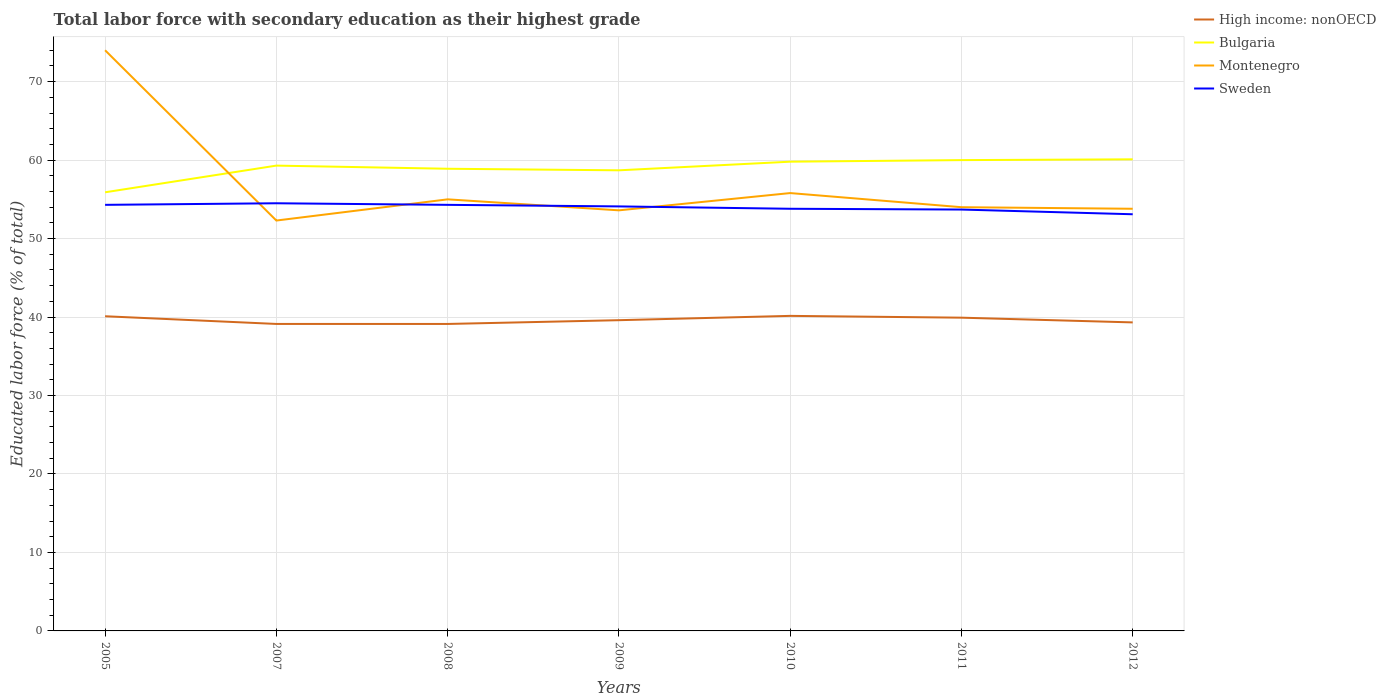Does the line corresponding to Montenegro intersect with the line corresponding to Sweden?
Your response must be concise. Yes. Across all years, what is the maximum percentage of total labor force with primary education in High income: nonOECD?
Keep it short and to the point. 39.12. In which year was the percentage of total labor force with primary education in Bulgaria maximum?
Ensure brevity in your answer.  2005. What is the total percentage of total labor force with primary education in High income: nonOECD in the graph?
Make the answer very short. -0.48. What is the difference between the highest and the second highest percentage of total labor force with primary education in Bulgaria?
Ensure brevity in your answer.  4.2. How many lines are there?
Offer a terse response. 4. Does the graph contain any zero values?
Your answer should be compact. No. How many legend labels are there?
Your response must be concise. 4. What is the title of the graph?
Your response must be concise. Total labor force with secondary education as their highest grade. What is the label or title of the Y-axis?
Keep it short and to the point. Educated labor force (% of total). What is the Educated labor force (% of total) of High income: nonOECD in 2005?
Your response must be concise. 40.1. What is the Educated labor force (% of total) in Bulgaria in 2005?
Your answer should be very brief. 55.9. What is the Educated labor force (% of total) in Sweden in 2005?
Make the answer very short. 54.3. What is the Educated labor force (% of total) of High income: nonOECD in 2007?
Keep it short and to the point. 39.12. What is the Educated labor force (% of total) of Bulgaria in 2007?
Ensure brevity in your answer.  59.3. What is the Educated labor force (% of total) in Montenegro in 2007?
Keep it short and to the point. 52.3. What is the Educated labor force (% of total) of Sweden in 2007?
Offer a terse response. 54.5. What is the Educated labor force (% of total) of High income: nonOECD in 2008?
Provide a short and direct response. 39.12. What is the Educated labor force (% of total) in Bulgaria in 2008?
Provide a short and direct response. 58.9. What is the Educated labor force (% of total) in Montenegro in 2008?
Keep it short and to the point. 55. What is the Educated labor force (% of total) in Sweden in 2008?
Ensure brevity in your answer.  54.3. What is the Educated labor force (% of total) in High income: nonOECD in 2009?
Offer a terse response. 39.6. What is the Educated labor force (% of total) in Bulgaria in 2009?
Ensure brevity in your answer.  58.7. What is the Educated labor force (% of total) of Montenegro in 2009?
Your response must be concise. 53.6. What is the Educated labor force (% of total) in Sweden in 2009?
Provide a succinct answer. 54.1. What is the Educated labor force (% of total) in High income: nonOECD in 2010?
Keep it short and to the point. 40.15. What is the Educated labor force (% of total) in Bulgaria in 2010?
Ensure brevity in your answer.  59.8. What is the Educated labor force (% of total) of Montenegro in 2010?
Provide a succinct answer. 55.8. What is the Educated labor force (% of total) in Sweden in 2010?
Offer a very short reply. 53.8. What is the Educated labor force (% of total) of High income: nonOECD in 2011?
Give a very brief answer. 39.92. What is the Educated labor force (% of total) in Montenegro in 2011?
Offer a very short reply. 54. What is the Educated labor force (% of total) in Sweden in 2011?
Your answer should be very brief. 53.7. What is the Educated labor force (% of total) of High income: nonOECD in 2012?
Provide a succinct answer. 39.32. What is the Educated labor force (% of total) in Bulgaria in 2012?
Give a very brief answer. 60.1. What is the Educated labor force (% of total) in Montenegro in 2012?
Your answer should be compact. 53.8. What is the Educated labor force (% of total) of Sweden in 2012?
Keep it short and to the point. 53.1. Across all years, what is the maximum Educated labor force (% of total) in High income: nonOECD?
Your response must be concise. 40.15. Across all years, what is the maximum Educated labor force (% of total) in Bulgaria?
Your response must be concise. 60.1. Across all years, what is the maximum Educated labor force (% of total) in Sweden?
Keep it short and to the point. 54.5. Across all years, what is the minimum Educated labor force (% of total) of High income: nonOECD?
Provide a succinct answer. 39.12. Across all years, what is the minimum Educated labor force (% of total) of Bulgaria?
Give a very brief answer. 55.9. Across all years, what is the minimum Educated labor force (% of total) of Montenegro?
Offer a very short reply. 52.3. Across all years, what is the minimum Educated labor force (% of total) in Sweden?
Give a very brief answer. 53.1. What is the total Educated labor force (% of total) of High income: nonOECD in the graph?
Your answer should be compact. 277.33. What is the total Educated labor force (% of total) of Bulgaria in the graph?
Make the answer very short. 412.7. What is the total Educated labor force (% of total) of Montenegro in the graph?
Your response must be concise. 398.5. What is the total Educated labor force (% of total) of Sweden in the graph?
Keep it short and to the point. 377.8. What is the difference between the Educated labor force (% of total) in High income: nonOECD in 2005 and that in 2007?
Your response must be concise. 0.98. What is the difference between the Educated labor force (% of total) in Montenegro in 2005 and that in 2007?
Your response must be concise. 21.7. What is the difference between the Educated labor force (% of total) of Sweden in 2005 and that in 2007?
Give a very brief answer. -0.2. What is the difference between the Educated labor force (% of total) in High income: nonOECD in 2005 and that in 2008?
Provide a succinct answer. 0.98. What is the difference between the Educated labor force (% of total) in Bulgaria in 2005 and that in 2008?
Keep it short and to the point. -3. What is the difference between the Educated labor force (% of total) of High income: nonOECD in 2005 and that in 2009?
Offer a terse response. 0.5. What is the difference between the Educated labor force (% of total) of Montenegro in 2005 and that in 2009?
Give a very brief answer. 20.4. What is the difference between the Educated labor force (% of total) in High income: nonOECD in 2005 and that in 2010?
Provide a short and direct response. -0.05. What is the difference between the Educated labor force (% of total) in Bulgaria in 2005 and that in 2010?
Ensure brevity in your answer.  -3.9. What is the difference between the Educated labor force (% of total) in High income: nonOECD in 2005 and that in 2011?
Offer a terse response. 0.18. What is the difference between the Educated labor force (% of total) in Bulgaria in 2005 and that in 2011?
Offer a very short reply. -4.1. What is the difference between the Educated labor force (% of total) in High income: nonOECD in 2005 and that in 2012?
Offer a very short reply. 0.78. What is the difference between the Educated labor force (% of total) in Bulgaria in 2005 and that in 2012?
Provide a succinct answer. -4.2. What is the difference between the Educated labor force (% of total) in Montenegro in 2005 and that in 2012?
Provide a short and direct response. 20.2. What is the difference between the Educated labor force (% of total) in High income: nonOECD in 2007 and that in 2008?
Offer a very short reply. 0. What is the difference between the Educated labor force (% of total) of Montenegro in 2007 and that in 2008?
Your answer should be compact. -2.7. What is the difference between the Educated labor force (% of total) of Sweden in 2007 and that in 2008?
Your answer should be compact. 0.2. What is the difference between the Educated labor force (% of total) in High income: nonOECD in 2007 and that in 2009?
Provide a short and direct response. -0.48. What is the difference between the Educated labor force (% of total) in Bulgaria in 2007 and that in 2009?
Keep it short and to the point. 0.6. What is the difference between the Educated labor force (% of total) in High income: nonOECD in 2007 and that in 2010?
Provide a succinct answer. -1.03. What is the difference between the Educated labor force (% of total) of Bulgaria in 2007 and that in 2010?
Your answer should be compact. -0.5. What is the difference between the Educated labor force (% of total) of High income: nonOECD in 2007 and that in 2011?
Ensure brevity in your answer.  -0.8. What is the difference between the Educated labor force (% of total) of Montenegro in 2007 and that in 2011?
Keep it short and to the point. -1.7. What is the difference between the Educated labor force (% of total) in Sweden in 2007 and that in 2011?
Your answer should be very brief. 0.8. What is the difference between the Educated labor force (% of total) of High income: nonOECD in 2007 and that in 2012?
Keep it short and to the point. -0.2. What is the difference between the Educated labor force (% of total) in Bulgaria in 2007 and that in 2012?
Provide a short and direct response. -0.8. What is the difference between the Educated labor force (% of total) in High income: nonOECD in 2008 and that in 2009?
Make the answer very short. -0.48. What is the difference between the Educated labor force (% of total) of Bulgaria in 2008 and that in 2009?
Provide a short and direct response. 0.2. What is the difference between the Educated labor force (% of total) in Sweden in 2008 and that in 2009?
Your answer should be very brief. 0.2. What is the difference between the Educated labor force (% of total) in High income: nonOECD in 2008 and that in 2010?
Keep it short and to the point. -1.03. What is the difference between the Educated labor force (% of total) of Bulgaria in 2008 and that in 2010?
Your answer should be very brief. -0.9. What is the difference between the Educated labor force (% of total) of High income: nonOECD in 2008 and that in 2011?
Provide a succinct answer. -0.8. What is the difference between the Educated labor force (% of total) of Bulgaria in 2008 and that in 2011?
Ensure brevity in your answer.  -1.1. What is the difference between the Educated labor force (% of total) in Montenegro in 2008 and that in 2011?
Ensure brevity in your answer.  1. What is the difference between the Educated labor force (% of total) in High income: nonOECD in 2008 and that in 2012?
Ensure brevity in your answer.  -0.2. What is the difference between the Educated labor force (% of total) of Sweden in 2008 and that in 2012?
Provide a short and direct response. 1.2. What is the difference between the Educated labor force (% of total) in High income: nonOECD in 2009 and that in 2010?
Ensure brevity in your answer.  -0.55. What is the difference between the Educated labor force (% of total) of Bulgaria in 2009 and that in 2010?
Make the answer very short. -1.1. What is the difference between the Educated labor force (% of total) in High income: nonOECD in 2009 and that in 2011?
Your response must be concise. -0.32. What is the difference between the Educated labor force (% of total) in High income: nonOECD in 2009 and that in 2012?
Your answer should be compact. 0.28. What is the difference between the Educated labor force (% of total) in Sweden in 2009 and that in 2012?
Provide a short and direct response. 1. What is the difference between the Educated labor force (% of total) in High income: nonOECD in 2010 and that in 2011?
Offer a terse response. 0.23. What is the difference between the Educated labor force (% of total) of Bulgaria in 2010 and that in 2011?
Your answer should be very brief. -0.2. What is the difference between the Educated labor force (% of total) in Sweden in 2010 and that in 2011?
Provide a short and direct response. 0.1. What is the difference between the Educated labor force (% of total) in High income: nonOECD in 2010 and that in 2012?
Your answer should be compact. 0.83. What is the difference between the Educated labor force (% of total) of Montenegro in 2010 and that in 2012?
Make the answer very short. 2. What is the difference between the Educated labor force (% of total) of Sweden in 2010 and that in 2012?
Provide a short and direct response. 0.7. What is the difference between the Educated labor force (% of total) in High income: nonOECD in 2011 and that in 2012?
Your answer should be compact. 0.6. What is the difference between the Educated labor force (% of total) in Bulgaria in 2011 and that in 2012?
Your response must be concise. -0.1. What is the difference between the Educated labor force (% of total) of High income: nonOECD in 2005 and the Educated labor force (% of total) of Bulgaria in 2007?
Keep it short and to the point. -19.2. What is the difference between the Educated labor force (% of total) in High income: nonOECD in 2005 and the Educated labor force (% of total) in Montenegro in 2007?
Give a very brief answer. -12.2. What is the difference between the Educated labor force (% of total) of High income: nonOECD in 2005 and the Educated labor force (% of total) of Sweden in 2007?
Ensure brevity in your answer.  -14.4. What is the difference between the Educated labor force (% of total) of Bulgaria in 2005 and the Educated labor force (% of total) of Sweden in 2007?
Your answer should be very brief. 1.4. What is the difference between the Educated labor force (% of total) in Montenegro in 2005 and the Educated labor force (% of total) in Sweden in 2007?
Offer a terse response. 19.5. What is the difference between the Educated labor force (% of total) in High income: nonOECD in 2005 and the Educated labor force (% of total) in Bulgaria in 2008?
Your answer should be compact. -18.8. What is the difference between the Educated labor force (% of total) in High income: nonOECD in 2005 and the Educated labor force (% of total) in Montenegro in 2008?
Your answer should be very brief. -14.9. What is the difference between the Educated labor force (% of total) in High income: nonOECD in 2005 and the Educated labor force (% of total) in Sweden in 2008?
Provide a succinct answer. -14.2. What is the difference between the Educated labor force (% of total) in Bulgaria in 2005 and the Educated labor force (% of total) in Montenegro in 2008?
Your response must be concise. 0.9. What is the difference between the Educated labor force (% of total) of High income: nonOECD in 2005 and the Educated labor force (% of total) of Bulgaria in 2009?
Your response must be concise. -18.6. What is the difference between the Educated labor force (% of total) of High income: nonOECD in 2005 and the Educated labor force (% of total) of Montenegro in 2009?
Keep it short and to the point. -13.5. What is the difference between the Educated labor force (% of total) in High income: nonOECD in 2005 and the Educated labor force (% of total) in Sweden in 2009?
Your response must be concise. -14. What is the difference between the Educated labor force (% of total) in Bulgaria in 2005 and the Educated labor force (% of total) in Montenegro in 2009?
Provide a succinct answer. 2.3. What is the difference between the Educated labor force (% of total) of High income: nonOECD in 2005 and the Educated labor force (% of total) of Bulgaria in 2010?
Your response must be concise. -19.7. What is the difference between the Educated labor force (% of total) in High income: nonOECD in 2005 and the Educated labor force (% of total) in Montenegro in 2010?
Your answer should be very brief. -15.7. What is the difference between the Educated labor force (% of total) of High income: nonOECD in 2005 and the Educated labor force (% of total) of Sweden in 2010?
Offer a terse response. -13.7. What is the difference between the Educated labor force (% of total) in Montenegro in 2005 and the Educated labor force (% of total) in Sweden in 2010?
Your response must be concise. 20.2. What is the difference between the Educated labor force (% of total) in High income: nonOECD in 2005 and the Educated labor force (% of total) in Bulgaria in 2011?
Your answer should be very brief. -19.9. What is the difference between the Educated labor force (% of total) of High income: nonOECD in 2005 and the Educated labor force (% of total) of Montenegro in 2011?
Make the answer very short. -13.9. What is the difference between the Educated labor force (% of total) in High income: nonOECD in 2005 and the Educated labor force (% of total) in Sweden in 2011?
Keep it short and to the point. -13.6. What is the difference between the Educated labor force (% of total) of Bulgaria in 2005 and the Educated labor force (% of total) of Sweden in 2011?
Your response must be concise. 2.2. What is the difference between the Educated labor force (% of total) in Montenegro in 2005 and the Educated labor force (% of total) in Sweden in 2011?
Your answer should be very brief. 20.3. What is the difference between the Educated labor force (% of total) of High income: nonOECD in 2005 and the Educated labor force (% of total) of Bulgaria in 2012?
Provide a succinct answer. -20. What is the difference between the Educated labor force (% of total) in High income: nonOECD in 2005 and the Educated labor force (% of total) in Montenegro in 2012?
Offer a terse response. -13.7. What is the difference between the Educated labor force (% of total) in High income: nonOECD in 2005 and the Educated labor force (% of total) in Sweden in 2012?
Provide a succinct answer. -13. What is the difference between the Educated labor force (% of total) of Bulgaria in 2005 and the Educated labor force (% of total) of Montenegro in 2012?
Ensure brevity in your answer.  2.1. What is the difference between the Educated labor force (% of total) in Montenegro in 2005 and the Educated labor force (% of total) in Sweden in 2012?
Ensure brevity in your answer.  20.9. What is the difference between the Educated labor force (% of total) of High income: nonOECD in 2007 and the Educated labor force (% of total) of Bulgaria in 2008?
Ensure brevity in your answer.  -19.78. What is the difference between the Educated labor force (% of total) of High income: nonOECD in 2007 and the Educated labor force (% of total) of Montenegro in 2008?
Provide a short and direct response. -15.88. What is the difference between the Educated labor force (% of total) in High income: nonOECD in 2007 and the Educated labor force (% of total) in Sweden in 2008?
Make the answer very short. -15.18. What is the difference between the Educated labor force (% of total) in Bulgaria in 2007 and the Educated labor force (% of total) in Montenegro in 2008?
Give a very brief answer. 4.3. What is the difference between the Educated labor force (% of total) of Bulgaria in 2007 and the Educated labor force (% of total) of Sweden in 2008?
Your response must be concise. 5. What is the difference between the Educated labor force (% of total) of High income: nonOECD in 2007 and the Educated labor force (% of total) of Bulgaria in 2009?
Offer a terse response. -19.58. What is the difference between the Educated labor force (% of total) of High income: nonOECD in 2007 and the Educated labor force (% of total) of Montenegro in 2009?
Your answer should be compact. -14.48. What is the difference between the Educated labor force (% of total) of High income: nonOECD in 2007 and the Educated labor force (% of total) of Sweden in 2009?
Keep it short and to the point. -14.98. What is the difference between the Educated labor force (% of total) of High income: nonOECD in 2007 and the Educated labor force (% of total) of Bulgaria in 2010?
Offer a terse response. -20.68. What is the difference between the Educated labor force (% of total) of High income: nonOECD in 2007 and the Educated labor force (% of total) of Montenegro in 2010?
Make the answer very short. -16.68. What is the difference between the Educated labor force (% of total) in High income: nonOECD in 2007 and the Educated labor force (% of total) in Sweden in 2010?
Offer a terse response. -14.68. What is the difference between the Educated labor force (% of total) of Bulgaria in 2007 and the Educated labor force (% of total) of Sweden in 2010?
Ensure brevity in your answer.  5.5. What is the difference between the Educated labor force (% of total) in Montenegro in 2007 and the Educated labor force (% of total) in Sweden in 2010?
Provide a succinct answer. -1.5. What is the difference between the Educated labor force (% of total) of High income: nonOECD in 2007 and the Educated labor force (% of total) of Bulgaria in 2011?
Ensure brevity in your answer.  -20.88. What is the difference between the Educated labor force (% of total) in High income: nonOECD in 2007 and the Educated labor force (% of total) in Montenegro in 2011?
Your answer should be compact. -14.88. What is the difference between the Educated labor force (% of total) of High income: nonOECD in 2007 and the Educated labor force (% of total) of Sweden in 2011?
Offer a very short reply. -14.58. What is the difference between the Educated labor force (% of total) of Bulgaria in 2007 and the Educated labor force (% of total) of Sweden in 2011?
Provide a short and direct response. 5.6. What is the difference between the Educated labor force (% of total) of Montenegro in 2007 and the Educated labor force (% of total) of Sweden in 2011?
Provide a short and direct response. -1.4. What is the difference between the Educated labor force (% of total) in High income: nonOECD in 2007 and the Educated labor force (% of total) in Bulgaria in 2012?
Your response must be concise. -20.98. What is the difference between the Educated labor force (% of total) in High income: nonOECD in 2007 and the Educated labor force (% of total) in Montenegro in 2012?
Your response must be concise. -14.68. What is the difference between the Educated labor force (% of total) of High income: nonOECD in 2007 and the Educated labor force (% of total) of Sweden in 2012?
Provide a succinct answer. -13.98. What is the difference between the Educated labor force (% of total) of Bulgaria in 2007 and the Educated labor force (% of total) of Sweden in 2012?
Provide a succinct answer. 6.2. What is the difference between the Educated labor force (% of total) of Montenegro in 2007 and the Educated labor force (% of total) of Sweden in 2012?
Keep it short and to the point. -0.8. What is the difference between the Educated labor force (% of total) in High income: nonOECD in 2008 and the Educated labor force (% of total) in Bulgaria in 2009?
Give a very brief answer. -19.58. What is the difference between the Educated labor force (% of total) of High income: nonOECD in 2008 and the Educated labor force (% of total) of Montenegro in 2009?
Give a very brief answer. -14.48. What is the difference between the Educated labor force (% of total) of High income: nonOECD in 2008 and the Educated labor force (% of total) of Sweden in 2009?
Keep it short and to the point. -14.98. What is the difference between the Educated labor force (% of total) in Bulgaria in 2008 and the Educated labor force (% of total) in Sweden in 2009?
Provide a short and direct response. 4.8. What is the difference between the Educated labor force (% of total) in High income: nonOECD in 2008 and the Educated labor force (% of total) in Bulgaria in 2010?
Provide a succinct answer. -20.68. What is the difference between the Educated labor force (% of total) in High income: nonOECD in 2008 and the Educated labor force (% of total) in Montenegro in 2010?
Offer a very short reply. -16.68. What is the difference between the Educated labor force (% of total) of High income: nonOECD in 2008 and the Educated labor force (% of total) of Sweden in 2010?
Provide a short and direct response. -14.68. What is the difference between the Educated labor force (% of total) in Bulgaria in 2008 and the Educated labor force (% of total) in Sweden in 2010?
Your answer should be very brief. 5.1. What is the difference between the Educated labor force (% of total) in Montenegro in 2008 and the Educated labor force (% of total) in Sweden in 2010?
Provide a succinct answer. 1.2. What is the difference between the Educated labor force (% of total) of High income: nonOECD in 2008 and the Educated labor force (% of total) of Bulgaria in 2011?
Offer a terse response. -20.88. What is the difference between the Educated labor force (% of total) in High income: nonOECD in 2008 and the Educated labor force (% of total) in Montenegro in 2011?
Make the answer very short. -14.88. What is the difference between the Educated labor force (% of total) in High income: nonOECD in 2008 and the Educated labor force (% of total) in Sweden in 2011?
Provide a succinct answer. -14.58. What is the difference between the Educated labor force (% of total) in Montenegro in 2008 and the Educated labor force (% of total) in Sweden in 2011?
Offer a terse response. 1.3. What is the difference between the Educated labor force (% of total) of High income: nonOECD in 2008 and the Educated labor force (% of total) of Bulgaria in 2012?
Provide a short and direct response. -20.98. What is the difference between the Educated labor force (% of total) of High income: nonOECD in 2008 and the Educated labor force (% of total) of Montenegro in 2012?
Offer a terse response. -14.68. What is the difference between the Educated labor force (% of total) of High income: nonOECD in 2008 and the Educated labor force (% of total) of Sweden in 2012?
Offer a very short reply. -13.98. What is the difference between the Educated labor force (% of total) in Montenegro in 2008 and the Educated labor force (% of total) in Sweden in 2012?
Ensure brevity in your answer.  1.9. What is the difference between the Educated labor force (% of total) in High income: nonOECD in 2009 and the Educated labor force (% of total) in Bulgaria in 2010?
Your answer should be compact. -20.2. What is the difference between the Educated labor force (% of total) in High income: nonOECD in 2009 and the Educated labor force (% of total) in Montenegro in 2010?
Provide a short and direct response. -16.2. What is the difference between the Educated labor force (% of total) in High income: nonOECD in 2009 and the Educated labor force (% of total) in Sweden in 2010?
Make the answer very short. -14.2. What is the difference between the Educated labor force (% of total) of Bulgaria in 2009 and the Educated labor force (% of total) of Montenegro in 2010?
Provide a short and direct response. 2.9. What is the difference between the Educated labor force (% of total) of Bulgaria in 2009 and the Educated labor force (% of total) of Sweden in 2010?
Keep it short and to the point. 4.9. What is the difference between the Educated labor force (% of total) of High income: nonOECD in 2009 and the Educated labor force (% of total) of Bulgaria in 2011?
Provide a succinct answer. -20.4. What is the difference between the Educated labor force (% of total) of High income: nonOECD in 2009 and the Educated labor force (% of total) of Montenegro in 2011?
Make the answer very short. -14.4. What is the difference between the Educated labor force (% of total) of High income: nonOECD in 2009 and the Educated labor force (% of total) of Sweden in 2011?
Keep it short and to the point. -14.1. What is the difference between the Educated labor force (% of total) in Bulgaria in 2009 and the Educated labor force (% of total) in Montenegro in 2011?
Keep it short and to the point. 4.7. What is the difference between the Educated labor force (% of total) in Montenegro in 2009 and the Educated labor force (% of total) in Sweden in 2011?
Provide a short and direct response. -0.1. What is the difference between the Educated labor force (% of total) of High income: nonOECD in 2009 and the Educated labor force (% of total) of Bulgaria in 2012?
Your answer should be very brief. -20.5. What is the difference between the Educated labor force (% of total) of Bulgaria in 2009 and the Educated labor force (% of total) of Montenegro in 2012?
Offer a terse response. 4.9. What is the difference between the Educated labor force (% of total) of High income: nonOECD in 2010 and the Educated labor force (% of total) of Bulgaria in 2011?
Keep it short and to the point. -19.85. What is the difference between the Educated labor force (% of total) of High income: nonOECD in 2010 and the Educated labor force (% of total) of Montenegro in 2011?
Provide a short and direct response. -13.85. What is the difference between the Educated labor force (% of total) of High income: nonOECD in 2010 and the Educated labor force (% of total) of Sweden in 2011?
Your answer should be compact. -13.55. What is the difference between the Educated labor force (% of total) of Bulgaria in 2010 and the Educated labor force (% of total) of Montenegro in 2011?
Your answer should be very brief. 5.8. What is the difference between the Educated labor force (% of total) in High income: nonOECD in 2010 and the Educated labor force (% of total) in Bulgaria in 2012?
Your answer should be compact. -19.95. What is the difference between the Educated labor force (% of total) in High income: nonOECD in 2010 and the Educated labor force (% of total) in Montenegro in 2012?
Keep it short and to the point. -13.65. What is the difference between the Educated labor force (% of total) of High income: nonOECD in 2010 and the Educated labor force (% of total) of Sweden in 2012?
Your response must be concise. -12.95. What is the difference between the Educated labor force (% of total) in Bulgaria in 2010 and the Educated labor force (% of total) in Montenegro in 2012?
Keep it short and to the point. 6. What is the difference between the Educated labor force (% of total) of Bulgaria in 2010 and the Educated labor force (% of total) of Sweden in 2012?
Give a very brief answer. 6.7. What is the difference between the Educated labor force (% of total) in Montenegro in 2010 and the Educated labor force (% of total) in Sweden in 2012?
Make the answer very short. 2.7. What is the difference between the Educated labor force (% of total) of High income: nonOECD in 2011 and the Educated labor force (% of total) of Bulgaria in 2012?
Offer a very short reply. -20.18. What is the difference between the Educated labor force (% of total) of High income: nonOECD in 2011 and the Educated labor force (% of total) of Montenegro in 2012?
Your response must be concise. -13.88. What is the difference between the Educated labor force (% of total) in High income: nonOECD in 2011 and the Educated labor force (% of total) in Sweden in 2012?
Offer a terse response. -13.18. What is the difference between the Educated labor force (% of total) of Bulgaria in 2011 and the Educated labor force (% of total) of Sweden in 2012?
Provide a succinct answer. 6.9. What is the difference between the Educated labor force (% of total) of Montenegro in 2011 and the Educated labor force (% of total) of Sweden in 2012?
Give a very brief answer. 0.9. What is the average Educated labor force (% of total) of High income: nonOECD per year?
Provide a short and direct response. 39.62. What is the average Educated labor force (% of total) in Bulgaria per year?
Your answer should be very brief. 58.96. What is the average Educated labor force (% of total) of Montenegro per year?
Ensure brevity in your answer.  56.93. What is the average Educated labor force (% of total) in Sweden per year?
Make the answer very short. 53.97. In the year 2005, what is the difference between the Educated labor force (% of total) of High income: nonOECD and Educated labor force (% of total) of Bulgaria?
Make the answer very short. -15.8. In the year 2005, what is the difference between the Educated labor force (% of total) of High income: nonOECD and Educated labor force (% of total) of Montenegro?
Offer a terse response. -33.9. In the year 2005, what is the difference between the Educated labor force (% of total) of High income: nonOECD and Educated labor force (% of total) of Sweden?
Make the answer very short. -14.2. In the year 2005, what is the difference between the Educated labor force (% of total) in Bulgaria and Educated labor force (% of total) in Montenegro?
Ensure brevity in your answer.  -18.1. In the year 2005, what is the difference between the Educated labor force (% of total) in Montenegro and Educated labor force (% of total) in Sweden?
Your answer should be compact. 19.7. In the year 2007, what is the difference between the Educated labor force (% of total) in High income: nonOECD and Educated labor force (% of total) in Bulgaria?
Your answer should be compact. -20.18. In the year 2007, what is the difference between the Educated labor force (% of total) of High income: nonOECD and Educated labor force (% of total) of Montenegro?
Keep it short and to the point. -13.18. In the year 2007, what is the difference between the Educated labor force (% of total) in High income: nonOECD and Educated labor force (% of total) in Sweden?
Your answer should be very brief. -15.38. In the year 2008, what is the difference between the Educated labor force (% of total) in High income: nonOECD and Educated labor force (% of total) in Bulgaria?
Your answer should be very brief. -19.78. In the year 2008, what is the difference between the Educated labor force (% of total) in High income: nonOECD and Educated labor force (% of total) in Montenegro?
Your answer should be compact. -15.88. In the year 2008, what is the difference between the Educated labor force (% of total) of High income: nonOECD and Educated labor force (% of total) of Sweden?
Your answer should be compact. -15.18. In the year 2008, what is the difference between the Educated labor force (% of total) of Bulgaria and Educated labor force (% of total) of Sweden?
Provide a succinct answer. 4.6. In the year 2008, what is the difference between the Educated labor force (% of total) in Montenegro and Educated labor force (% of total) in Sweden?
Your response must be concise. 0.7. In the year 2009, what is the difference between the Educated labor force (% of total) in High income: nonOECD and Educated labor force (% of total) in Bulgaria?
Provide a short and direct response. -19.1. In the year 2009, what is the difference between the Educated labor force (% of total) of High income: nonOECD and Educated labor force (% of total) of Sweden?
Offer a terse response. -14.5. In the year 2009, what is the difference between the Educated labor force (% of total) of Bulgaria and Educated labor force (% of total) of Montenegro?
Offer a terse response. 5.1. In the year 2009, what is the difference between the Educated labor force (% of total) in Bulgaria and Educated labor force (% of total) in Sweden?
Ensure brevity in your answer.  4.6. In the year 2009, what is the difference between the Educated labor force (% of total) in Montenegro and Educated labor force (% of total) in Sweden?
Your response must be concise. -0.5. In the year 2010, what is the difference between the Educated labor force (% of total) in High income: nonOECD and Educated labor force (% of total) in Bulgaria?
Give a very brief answer. -19.65. In the year 2010, what is the difference between the Educated labor force (% of total) in High income: nonOECD and Educated labor force (% of total) in Montenegro?
Provide a short and direct response. -15.65. In the year 2010, what is the difference between the Educated labor force (% of total) of High income: nonOECD and Educated labor force (% of total) of Sweden?
Provide a short and direct response. -13.65. In the year 2010, what is the difference between the Educated labor force (% of total) in Bulgaria and Educated labor force (% of total) in Sweden?
Offer a terse response. 6. In the year 2011, what is the difference between the Educated labor force (% of total) in High income: nonOECD and Educated labor force (% of total) in Bulgaria?
Provide a succinct answer. -20.08. In the year 2011, what is the difference between the Educated labor force (% of total) in High income: nonOECD and Educated labor force (% of total) in Montenegro?
Your answer should be very brief. -14.08. In the year 2011, what is the difference between the Educated labor force (% of total) in High income: nonOECD and Educated labor force (% of total) in Sweden?
Your answer should be very brief. -13.78. In the year 2011, what is the difference between the Educated labor force (% of total) of Bulgaria and Educated labor force (% of total) of Montenegro?
Give a very brief answer. 6. In the year 2011, what is the difference between the Educated labor force (% of total) of Bulgaria and Educated labor force (% of total) of Sweden?
Offer a terse response. 6.3. In the year 2011, what is the difference between the Educated labor force (% of total) in Montenegro and Educated labor force (% of total) in Sweden?
Keep it short and to the point. 0.3. In the year 2012, what is the difference between the Educated labor force (% of total) in High income: nonOECD and Educated labor force (% of total) in Bulgaria?
Your answer should be very brief. -20.78. In the year 2012, what is the difference between the Educated labor force (% of total) in High income: nonOECD and Educated labor force (% of total) in Montenegro?
Your answer should be very brief. -14.48. In the year 2012, what is the difference between the Educated labor force (% of total) in High income: nonOECD and Educated labor force (% of total) in Sweden?
Ensure brevity in your answer.  -13.78. In the year 2012, what is the difference between the Educated labor force (% of total) of Bulgaria and Educated labor force (% of total) of Sweden?
Your answer should be compact. 7. In the year 2012, what is the difference between the Educated labor force (% of total) in Montenegro and Educated labor force (% of total) in Sweden?
Keep it short and to the point. 0.7. What is the ratio of the Educated labor force (% of total) of High income: nonOECD in 2005 to that in 2007?
Ensure brevity in your answer.  1.03. What is the ratio of the Educated labor force (% of total) in Bulgaria in 2005 to that in 2007?
Offer a very short reply. 0.94. What is the ratio of the Educated labor force (% of total) in Montenegro in 2005 to that in 2007?
Give a very brief answer. 1.41. What is the ratio of the Educated labor force (% of total) of High income: nonOECD in 2005 to that in 2008?
Make the answer very short. 1.03. What is the ratio of the Educated labor force (% of total) of Bulgaria in 2005 to that in 2008?
Offer a very short reply. 0.95. What is the ratio of the Educated labor force (% of total) in Montenegro in 2005 to that in 2008?
Give a very brief answer. 1.35. What is the ratio of the Educated labor force (% of total) of Sweden in 2005 to that in 2008?
Your answer should be very brief. 1. What is the ratio of the Educated labor force (% of total) of High income: nonOECD in 2005 to that in 2009?
Offer a very short reply. 1.01. What is the ratio of the Educated labor force (% of total) in Bulgaria in 2005 to that in 2009?
Your answer should be compact. 0.95. What is the ratio of the Educated labor force (% of total) of Montenegro in 2005 to that in 2009?
Keep it short and to the point. 1.38. What is the ratio of the Educated labor force (% of total) of High income: nonOECD in 2005 to that in 2010?
Your answer should be very brief. 1. What is the ratio of the Educated labor force (% of total) of Bulgaria in 2005 to that in 2010?
Your answer should be very brief. 0.93. What is the ratio of the Educated labor force (% of total) of Montenegro in 2005 to that in 2010?
Your response must be concise. 1.33. What is the ratio of the Educated labor force (% of total) of Sweden in 2005 to that in 2010?
Offer a terse response. 1.01. What is the ratio of the Educated labor force (% of total) of Bulgaria in 2005 to that in 2011?
Offer a very short reply. 0.93. What is the ratio of the Educated labor force (% of total) of Montenegro in 2005 to that in 2011?
Your answer should be compact. 1.37. What is the ratio of the Educated labor force (% of total) of Sweden in 2005 to that in 2011?
Your answer should be very brief. 1.01. What is the ratio of the Educated labor force (% of total) of High income: nonOECD in 2005 to that in 2012?
Keep it short and to the point. 1.02. What is the ratio of the Educated labor force (% of total) in Bulgaria in 2005 to that in 2012?
Your answer should be compact. 0.93. What is the ratio of the Educated labor force (% of total) in Montenegro in 2005 to that in 2012?
Provide a short and direct response. 1.38. What is the ratio of the Educated labor force (% of total) of Sweden in 2005 to that in 2012?
Your answer should be compact. 1.02. What is the ratio of the Educated labor force (% of total) of High income: nonOECD in 2007 to that in 2008?
Provide a short and direct response. 1. What is the ratio of the Educated labor force (% of total) in Bulgaria in 2007 to that in 2008?
Your response must be concise. 1.01. What is the ratio of the Educated labor force (% of total) in Montenegro in 2007 to that in 2008?
Your answer should be compact. 0.95. What is the ratio of the Educated labor force (% of total) in High income: nonOECD in 2007 to that in 2009?
Make the answer very short. 0.99. What is the ratio of the Educated labor force (% of total) in Bulgaria in 2007 to that in 2009?
Ensure brevity in your answer.  1.01. What is the ratio of the Educated labor force (% of total) in Montenegro in 2007 to that in 2009?
Keep it short and to the point. 0.98. What is the ratio of the Educated labor force (% of total) of Sweden in 2007 to that in 2009?
Your answer should be very brief. 1.01. What is the ratio of the Educated labor force (% of total) in High income: nonOECD in 2007 to that in 2010?
Offer a terse response. 0.97. What is the ratio of the Educated labor force (% of total) of Bulgaria in 2007 to that in 2010?
Your answer should be very brief. 0.99. What is the ratio of the Educated labor force (% of total) in Montenegro in 2007 to that in 2010?
Offer a terse response. 0.94. What is the ratio of the Educated labor force (% of total) in High income: nonOECD in 2007 to that in 2011?
Your response must be concise. 0.98. What is the ratio of the Educated labor force (% of total) of Bulgaria in 2007 to that in 2011?
Offer a very short reply. 0.99. What is the ratio of the Educated labor force (% of total) in Montenegro in 2007 to that in 2011?
Ensure brevity in your answer.  0.97. What is the ratio of the Educated labor force (% of total) of Sweden in 2007 to that in 2011?
Your response must be concise. 1.01. What is the ratio of the Educated labor force (% of total) in High income: nonOECD in 2007 to that in 2012?
Offer a very short reply. 0.99. What is the ratio of the Educated labor force (% of total) in Bulgaria in 2007 to that in 2012?
Provide a succinct answer. 0.99. What is the ratio of the Educated labor force (% of total) of Montenegro in 2007 to that in 2012?
Ensure brevity in your answer.  0.97. What is the ratio of the Educated labor force (% of total) of Sweden in 2007 to that in 2012?
Your response must be concise. 1.03. What is the ratio of the Educated labor force (% of total) in High income: nonOECD in 2008 to that in 2009?
Provide a short and direct response. 0.99. What is the ratio of the Educated labor force (% of total) in Montenegro in 2008 to that in 2009?
Your answer should be compact. 1.03. What is the ratio of the Educated labor force (% of total) of Sweden in 2008 to that in 2009?
Keep it short and to the point. 1. What is the ratio of the Educated labor force (% of total) of High income: nonOECD in 2008 to that in 2010?
Offer a very short reply. 0.97. What is the ratio of the Educated labor force (% of total) in Bulgaria in 2008 to that in 2010?
Keep it short and to the point. 0.98. What is the ratio of the Educated labor force (% of total) in Montenegro in 2008 to that in 2010?
Make the answer very short. 0.99. What is the ratio of the Educated labor force (% of total) in Sweden in 2008 to that in 2010?
Keep it short and to the point. 1.01. What is the ratio of the Educated labor force (% of total) in High income: nonOECD in 2008 to that in 2011?
Give a very brief answer. 0.98. What is the ratio of the Educated labor force (% of total) of Bulgaria in 2008 to that in 2011?
Your answer should be compact. 0.98. What is the ratio of the Educated labor force (% of total) of Montenegro in 2008 to that in 2011?
Make the answer very short. 1.02. What is the ratio of the Educated labor force (% of total) in Sweden in 2008 to that in 2011?
Your response must be concise. 1.01. What is the ratio of the Educated labor force (% of total) in High income: nonOECD in 2008 to that in 2012?
Give a very brief answer. 0.99. What is the ratio of the Educated labor force (% of total) of Bulgaria in 2008 to that in 2012?
Provide a succinct answer. 0.98. What is the ratio of the Educated labor force (% of total) in Montenegro in 2008 to that in 2012?
Your answer should be very brief. 1.02. What is the ratio of the Educated labor force (% of total) of Sweden in 2008 to that in 2012?
Ensure brevity in your answer.  1.02. What is the ratio of the Educated labor force (% of total) in High income: nonOECD in 2009 to that in 2010?
Your answer should be compact. 0.99. What is the ratio of the Educated labor force (% of total) of Bulgaria in 2009 to that in 2010?
Your answer should be very brief. 0.98. What is the ratio of the Educated labor force (% of total) of Montenegro in 2009 to that in 2010?
Your response must be concise. 0.96. What is the ratio of the Educated labor force (% of total) of Sweden in 2009 to that in 2010?
Your answer should be compact. 1.01. What is the ratio of the Educated labor force (% of total) in Bulgaria in 2009 to that in 2011?
Your answer should be very brief. 0.98. What is the ratio of the Educated labor force (% of total) of Montenegro in 2009 to that in 2011?
Ensure brevity in your answer.  0.99. What is the ratio of the Educated labor force (% of total) in Sweden in 2009 to that in 2011?
Provide a short and direct response. 1.01. What is the ratio of the Educated labor force (% of total) of High income: nonOECD in 2009 to that in 2012?
Your response must be concise. 1.01. What is the ratio of the Educated labor force (% of total) of Bulgaria in 2009 to that in 2012?
Your response must be concise. 0.98. What is the ratio of the Educated labor force (% of total) of Sweden in 2009 to that in 2012?
Provide a short and direct response. 1.02. What is the ratio of the Educated labor force (% of total) of Montenegro in 2010 to that in 2011?
Provide a succinct answer. 1.03. What is the ratio of the Educated labor force (% of total) of Sweden in 2010 to that in 2011?
Provide a succinct answer. 1. What is the ratio of the Educated labor force (% of total) of High income: nonOECD in 2010 to that in 2012?
Give a very brief answer. 1.02. What is the ratio of the Educated labor force (% of total) of Bulgaria in 2010 to that in 2012?
Provide a short and direct response. 0.99. What is the ratio of the Educated labor force (% of total) in Montenegro in 2010 to that in 2012?
Your answer should be compact. 1.04. What is the ratio of the Educated labor force (% of total) in Sweden in 2010 to that in 2012?
Provide a short and direct response. 1.01. What is the ratio of the Educated labor force (% of total) of High income: nonOECD in 2011 to that in 2012?
Make the answer very short. 1.02. What is the ratio of the Educated labor force (% of total) of Bulgaria in 2011 to that in 2012?
Your answer should be compact. 1. What is the ratio of the Educated labor force (% of total) of Sweden in 2011 to that in 2012?
Your answer should be very brief. 1.01. What is the difference between the highest and the second highest Educated labor force (% of total) of High income: nonOECD?
Your response must be concise. 0.05. What is the difference between the highest and the second highest Educated labor force (% of total) of Montenegro?
Your answer should be very brief. 18.2. What is the difference between the highest and the lowest Educated labor force (% of total) in High income: nonOECD?
Provide a succinct answer. 1.03. What is the difference between the highest and the lowest Educated labor force (% of total) of Bulgaria?
Ensure brevity in your answer.  4.2. What is the difference between the highest and the lowest Educated labor force (% of total) in Montenegro?
Your response must be concise. 21.7. What is the difference between the highest and the lowest Educated labor force (% of total) of Sweden?
Provide a short and direct response. 1.4. 